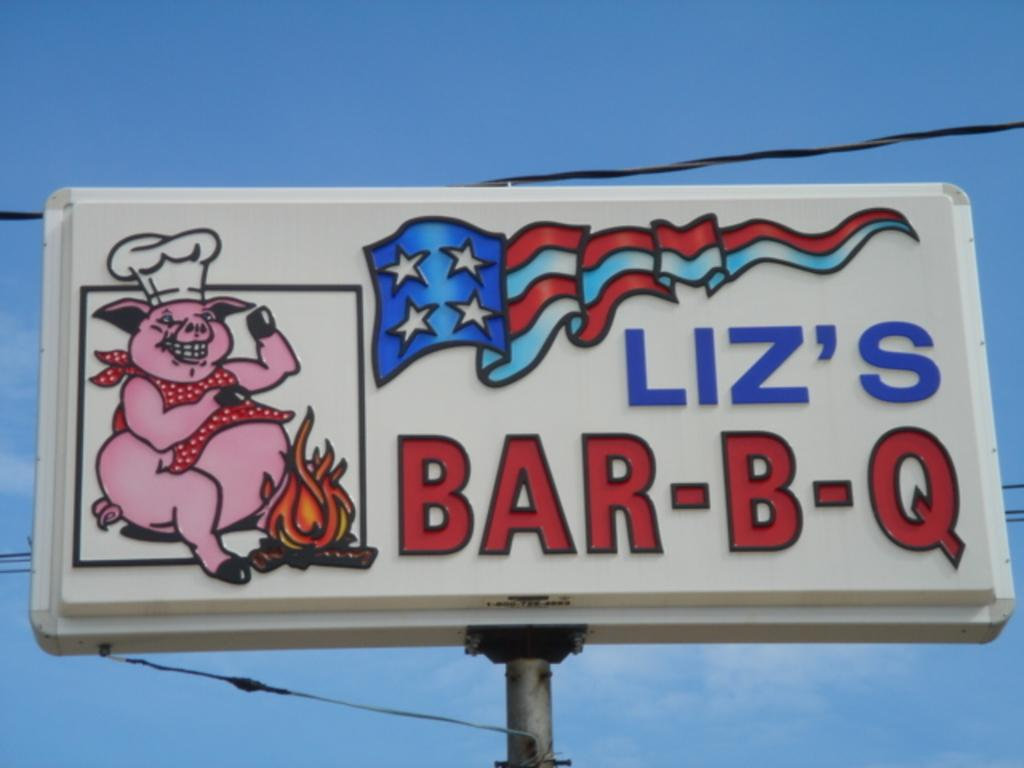<image>
Relay a brief, clear account of the picture shown. A billboard sign that says Liz's BAR-B-Q with a picture of a pig in a chef's hat. 